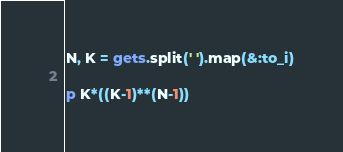Convert code to text. <code><loc_0><loc_0><loc_500><loc_500><_Ruby_>N, K = gets.split(' ').map(&:to_i)

p K*((K-1)**(N-1))</code> 